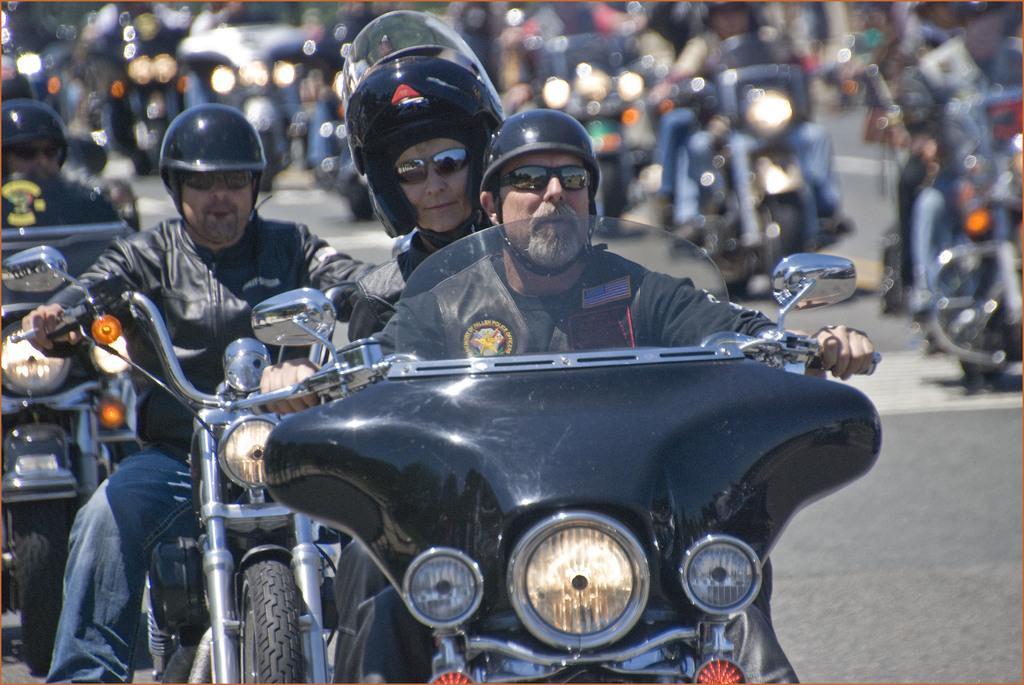Could you give a brief overview of what you see in this image? In this image i can see a group of people are riding bikes on the road. 